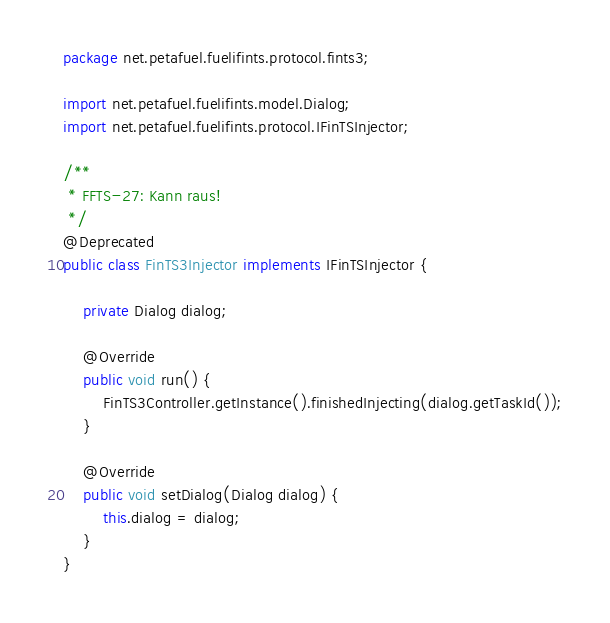Convert code to text. <code><loc_0><loc_0><loc_500><loc_500><_Java_>package net.petafuel.fuelifints.protocol.fints3;

import net.petafuel.fuelifints.model.Dialog;
import net.petafuel.fuelifints.protocol.IFinTSInjector;

/**
 * FFTS-27: Kann raus!
 */
@Deprecated
public class FinTS3Injector implements IFinTSInjector {

    private Dialog dialog;

    @Override
    public void run() {
        FinTS3Controller.getInstance().finishedInjecting(dialog.getTaskId());
    }

    @Override
    public void setDialog(Dialog dialog) {
        this.dialog = dialog;
    }
}
</code> 